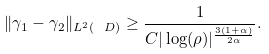<formula> <loc_0><loc_0><loc_500><loc_500>\| \gamma _ { 1 } - \gamma _ { 2 } \| _ { L ^ { 2 } ( \ D ) } \geq \frac { 1 } { C | \log ( \rho ) | ^ { \frac { 3 ( 1 + \alpha ) } { 2 \alpha } } } .</formula> 